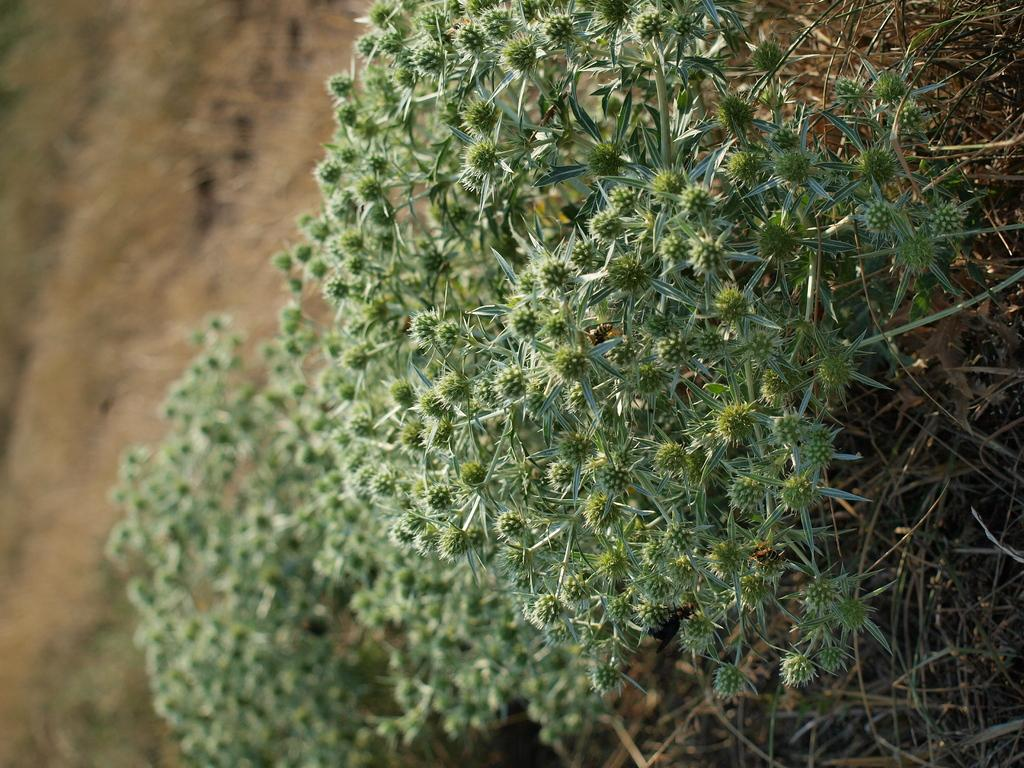What type of living organisms can be seen in the image? Plants can be seen in the image. Can you describe the background of the image? The background of the image is blurred. What time of day is it in the image? The time of day is not mentioned or visible in the image. Is there a club visible in the image? There is no club present in the image. What type of jam is being made in the image? There is no jam-making activity depicted in the image. 